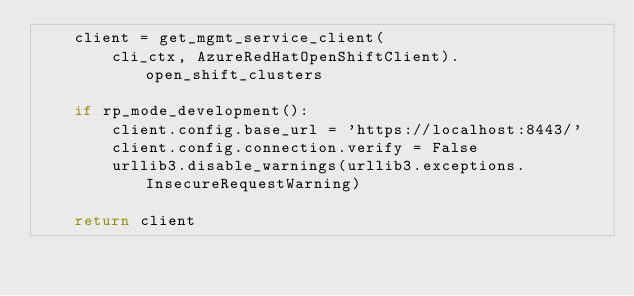<code> <loc_0><loc_0><loc_500><loc_500><_Python_>    client = get_mgmt_service_client(
        cli_ctx, AzureRedHatOpenShiftClient).open_shift_clusters

    if rp_mode_development():
        client.config.base_url = 'https://localhost:8443/'
        client.config.connection.verify = False
        urllib3.disable_warnings(urllib3.exceptions.InsecureRequestWarning)

    return client
</code> 